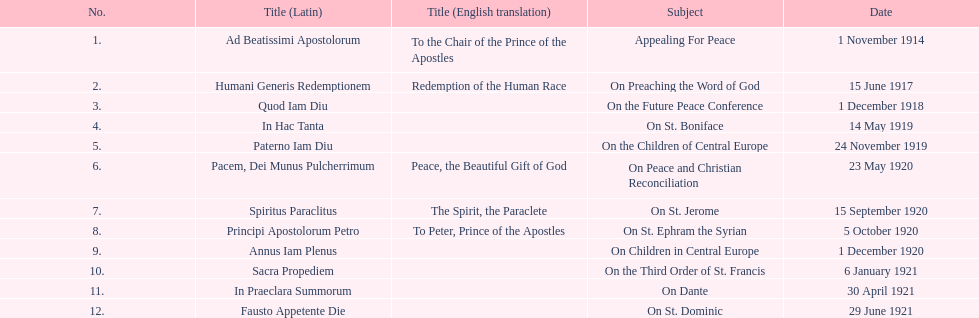Which english translation is mentioned first in the table? To the Chair of the Prince of the Apostles. 